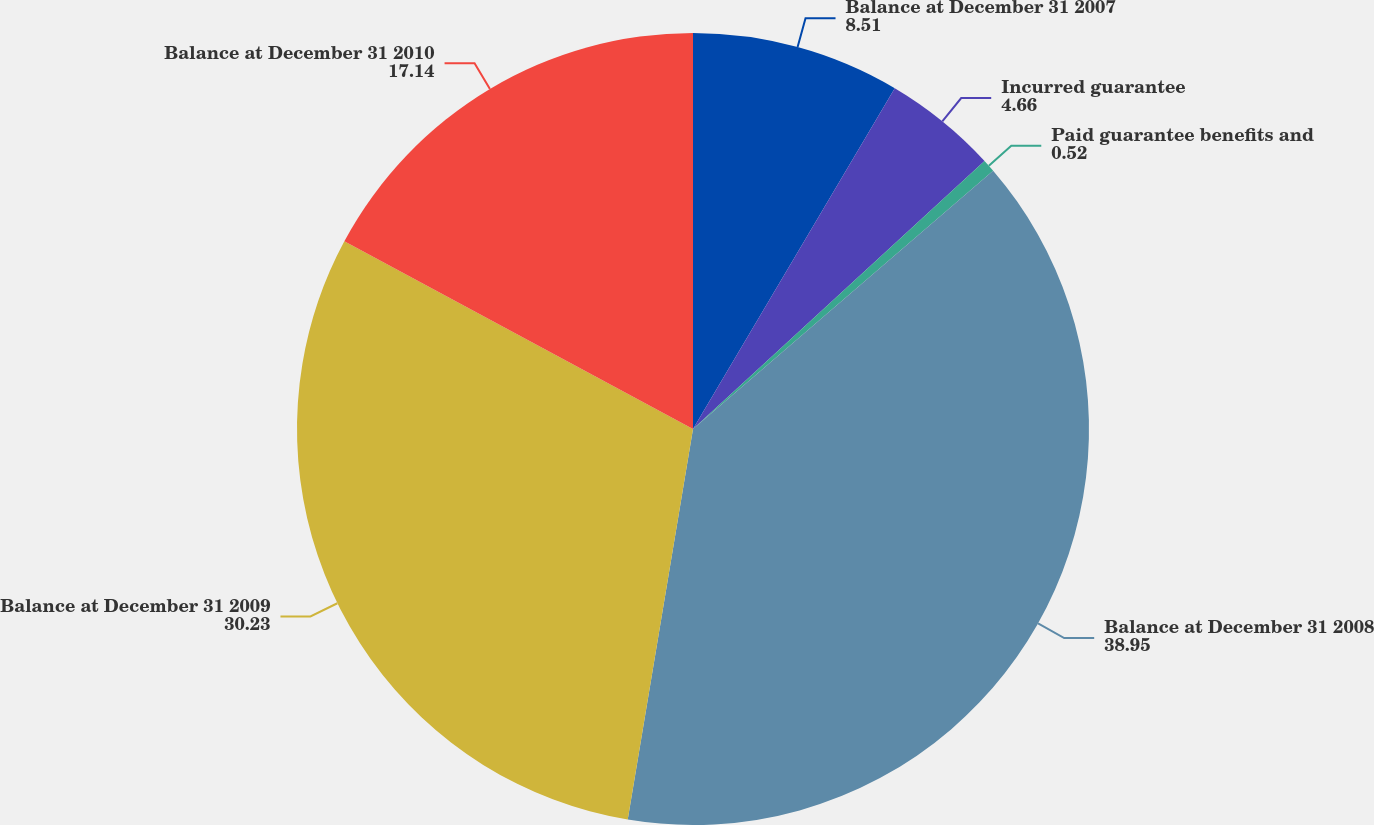Convert chart to OTSL. <chart><loc_0><loc_0><loc_500><loc_500><pie_chart><fcel>Balance at December 31 2007<fcel>Incurred guarantee<fcel>Paid guarantee benefits and<fcel>Balance at December 31 2008<fcel>Balance at December 31 2009<fcel>Balance at December 31 2010<nl><fcel>8.51%<fcel>4.66%<fcel>0.52%<fcel>38.95%<fcel>30.23%<fcel>17.14%<nl></chart> 